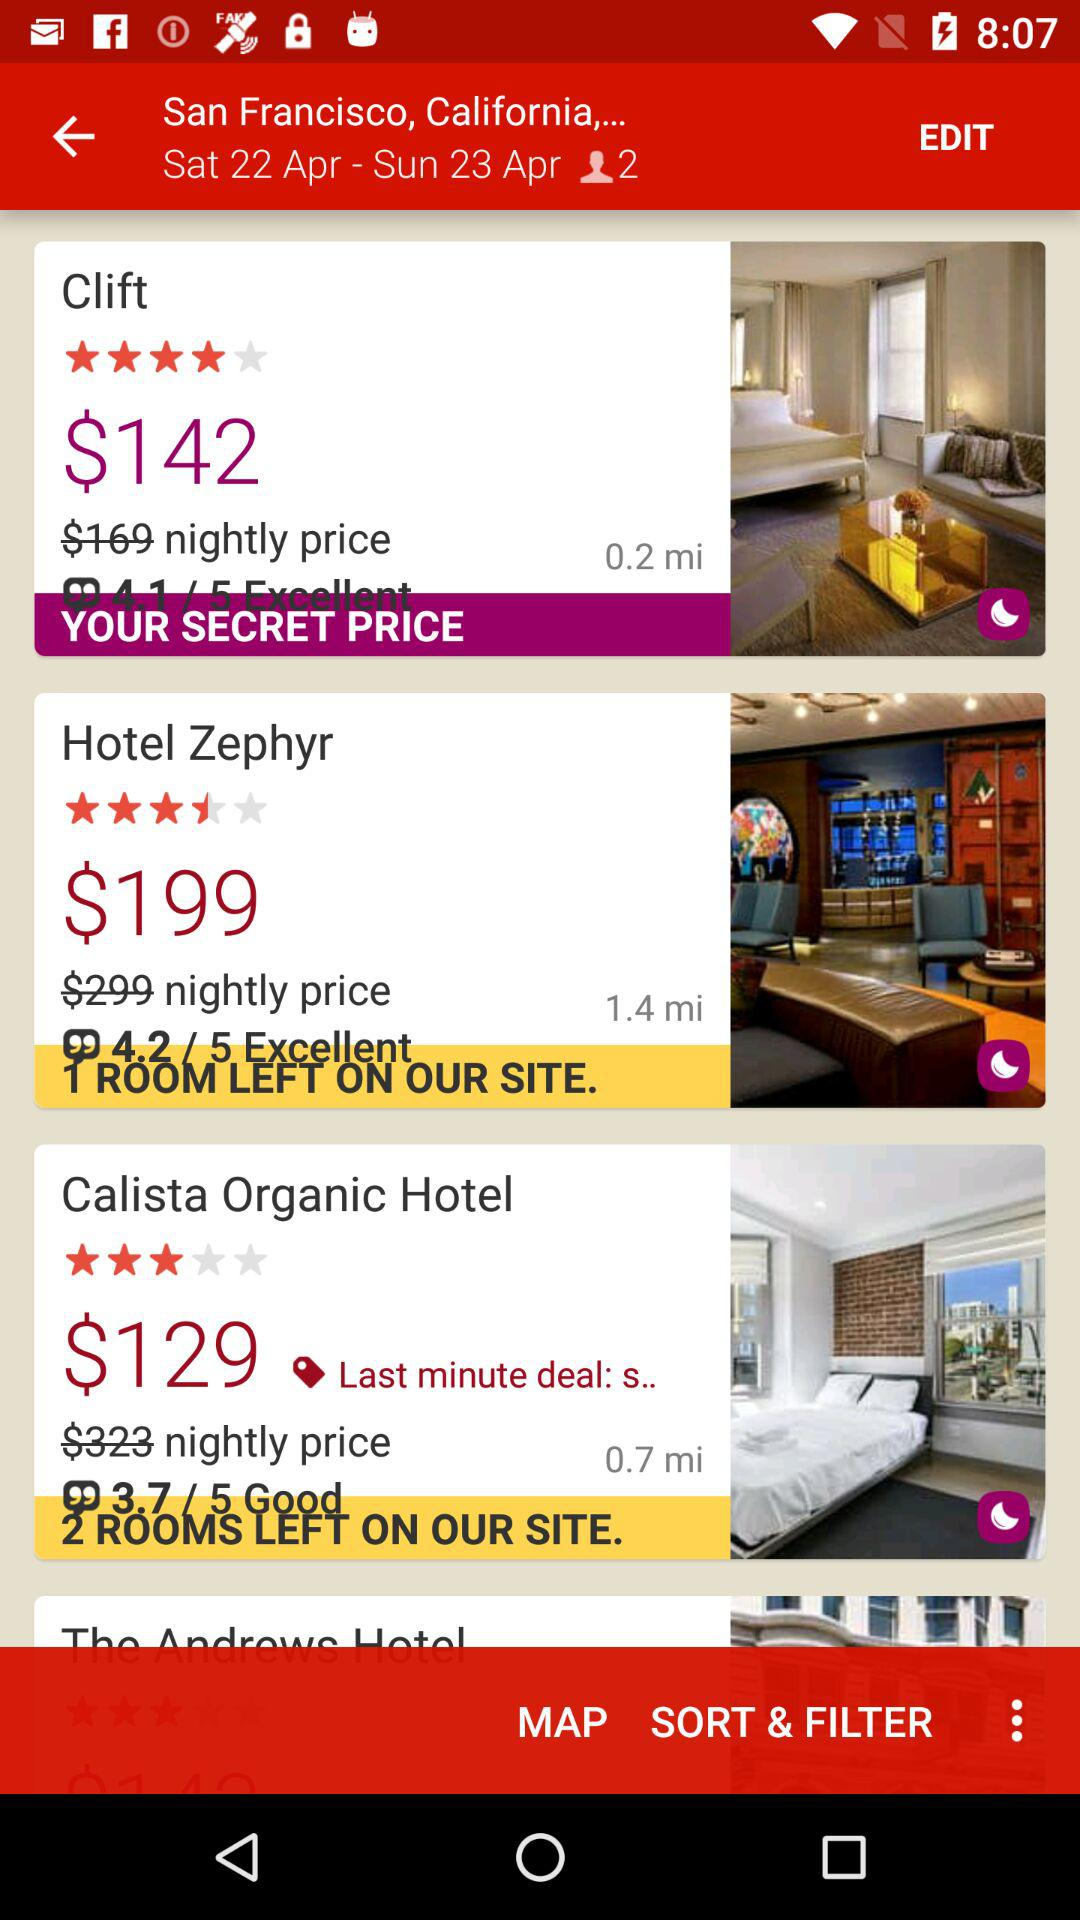What is the per-night price of the Hotel Zephyr? The per-night price of the Hotel Zephyr is $199. 